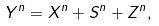<formula> <loc_0><loc_0><loc_500><loc_500>Y ^ { n } = X ^ { n } + { S } ^ { n } + Z ^ { n } ,</formula> 